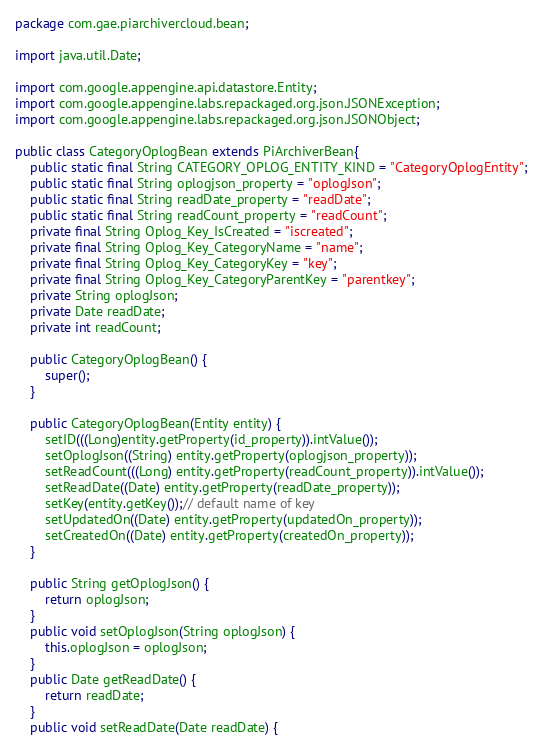Convert code to text. <code><loc_0><loc_0><loc_500><loc_500><_Java_>package com.gae.piarchivercloud.bean;

import java.util.Date;

import com.google.appengine.api.datastore.Entity;
import com.google.appengine.labs.repackaged.org.json.JSONException;
import com.google.appengine.labs.repackaged.org.json.JSONObject;

public class CategoryOplogBean extends PiArchiverBean{
	public static final String CATEGORY_OPLOG_ENTITY_KIND = "CategoryOplogEntity";
	public static final String oplogjson_property = "oplogJson";	
	public static final String readDate_property = "readDate";
	public static final String readCount_property = "readCount";
	private final String Oplog_Key_IsCreated = "iscreated";
	private final String Oplog_Key_CategoryName = "name";
	private final String Oplog_Key_CategoryKey = "key";
	private final String Oplog_Key_CategoryParentKey = "parentkey";
	private String oplogJson;
	private Date readDate;
	private int readCount;
	
	public CategoryOplogBean() {
		super();		
	}
	
	public CategoryOplogBean(Entity entity) {
		setID(((Long)entity.getProperty(id_property)).intValue());		
		setOplogJson((String) entity.getProperty(oplogjson_property));
		setReadCount(((Long) entity.getProperty(readCount_property)).intValue());
		setReadDate((Date) entity.getProperty(readDate_property));
		setKey(entity.getKey());// default name of key
		setUpdatedOn((Date) entity.getProperty(updatedOn_property));
		setCreatedOn((Date) entity.getProperty(createdOn_property));
	}
	
	public String getOplogJson() {
		return oplogJson;
	}
	public void setOplogJson(String oplogJson) {
		this.oplogJson = oplogJson;
	}
	public Date getReadDate() {
		return readDate;
	}
	public void setReadDate(Date readDate) {</code> 